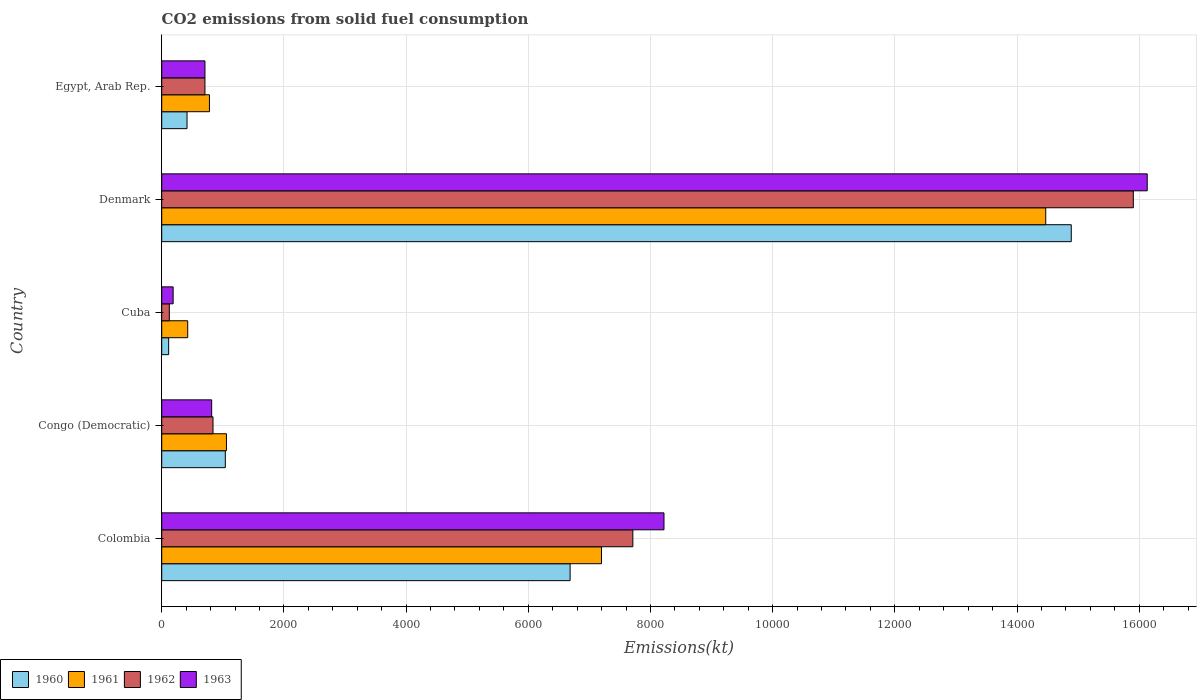Are the number of bars on each tick of the Y-axis equal?
Your response must be concise. Yes. What is the label of the 3rd group of bars from the top?
Offer a terse response. Cuba. What is the amount of CO2 emitted in 1963 in Cuba?
Keep it short and to the point. 187.02. Across all countries, what is the maximum amount of CO2 emitted in 1963?
Keep it short and to the point. 1.61e+04. Across all countries, what is the minimum amount of CO2 emitted in 1961?
Provide a succinct answer. 425.37. In which country was the amount of CO2 emitted in 1961 maximum?
Provide a succinct answer. Denmark. In which country was the amount of CO2 emitted in 1961 minimum?
Give a very brief answer. Cuba. What is the total amount of CO2 emitted in 1962 in the graph?
Make the answer very short. 2.53e+04. What is the difference between the amount of CO2 emitted in 1961 in Colombia and that in Egypt, Arab Rep.?
Offer a terse response. 6417.25. What is the difference between the amount of CO2 emitted in 1962 in Congo (Democratic) and the amount of CO2 emitted in 1963 in Colombia?
Offer a terse response. -7381.67. What is the average amount of CO2 emitted in 1960 per country?
Make the answer very short. 4628.49. What is the difference between the amount of CO2 emitted in 1962 and amount of CO2 emitted in 1961 in Denmark?
Provide a short and direct response. 1433.8. What is the ratio of the amount of CO2 emitted in 1961 in Congo (Democratic) to that in Egypt, Arab Rep.?
Ensure brevity in your answer.  1.36. Is the amount of CO2 emitted in 1960 in Congo (Democratic) less than that in Cuba?
Make the answer very short. No. Is the difference between the amount of CO2 emitted in 1962 in Cuba and Denmark greater than the difference between the amount of CO2 emitted in 1961 in Cuba and Denmark?
Make the answer very short. No. What is the difference between the highest and the second highest amount of CO2 emitted in 1961?
Provide a short and direct response. 7271.66. What is the difference between the highest and the lowest amount of CO2 emitted in 1960?
Offer a very short reply. 1.48e+04. Is it the case that in every country, the sum of the amount of CO2 emitted in 1962 and amount of CO2 emitted in 1963 is greater than the sum of amount of CO2 emitted in 1961 and amount of CO2 emitted in 1960?
Provide a succinct answer. No. What does the 3rd bar from the top in Cuba represents?
Provide a short and direct response. 1961. What does the 2nd bar from the bottom in Colombia represents?
Your response must be concise. 1961. Is it the case that in every country, the sum of the amount of CO2 emitted in 1960 and amount of CO2 emitted in 1961 is greater than the amount of CO2 emitted in 1962?
Ensure brevity in your answer.  Yes. How many bars are there?
Offer a terse response. 20. Are all the bars in the graph horizontal?
Offer a very short reply. Yes. Are the values on the major ticks of X-axis written in scientific E-notation?
Keep it short and to the point. No. Does the graph contain grids?
Provide a short and direct response. Yes. How many legend labels are there?
Your answer should be compact. 4. How are the legend labels stacked?
Your answer should be compact. Horizontal. What is the title of the graph?
Provide a short and direct response. CO2 emissions from solid fuel consumption. Does "1973" appear as one of the legend labels in the graph?
Your response must be concise. No. What is the label or title of the X-axis?
Give a very brief answer. Emissions(kt). What is the Emissions(kt) in 1960 in Colombia?
Offer a very short reply. 6684.94. What is the Emissions(kt) of 1961 in Colombia?
Your response must be concise. 7198.32. What is the Emissions(kt) in 1962 in Colombia?
Provide a succinct answer. 7711.7. What is the Emissions(kt) of 1963 in Colombia?
Your answer should be compact. 8221.41. What is the Emissions(kt) in 1960 in Congo (Democratic)?
Offer a very short reply. 1041.43. What is the Emissions(kt) of 1961 in Congo (Democratic)?
Offer a very short reply. 1059.76. What is the Emissions(kt) in 1962 in Congo (Democratic)?
Make the answer very short. 839.74. What is the Emissions(kt) of 1963 in Congo (Democratic)?
Ensure brevity in your answer.  817.74. What is the Emissions(kt) of 1960 in Cuba?
Offer a terse response. 113.68. What is the Emissions(kt) of 1961 in Cuba?
Make the answer very short. 425.37. What is the Emissions(kt) in 1962 in Cuba?
Provide a short and direct response. 124.68. What is the Emissions(kt) in 1963 in Cuba?
Your answer should be compact. 187.02. What is the Emissions(kt) in 1960 in Denmark?
Your answer should be very brief. 1.49e+04. What is the Emissions(kt) in 1961 in Denmark?
Make the answer very short. 1.45e+04. What is the Emissions(kt) in 1962 in Denmark?
Ensure brevity in your answer.  1.59e+04. What is the Emissions(kt) in 1963 in Denmark?
Your answer should be compact. 1.61e+04. What is the Emissions(kt) of 1960 in Egypt, Arab Rep.?
Offer a terse response. 414.37. What is the Emissions(kt) in 1961 in Egypt, Arab Rep.?
Offer a very short reply. 781.07. What is the Emissions(kt) in 1962 in Egypt, Arab Rep.?
Keep it short and to the point. 707.73. What is the Emissions(kt) in 1963 in Egypt, Arab Rep.?
Offer a terse response. 707.73. Across all countries, what is the maximum Emissions(kt) in 1960?
Your answer should be compact. 1.49e+04. Across all countries, what is the maximum Emissions(kt) of 1961?
Give a very brief answer. 1.45e+04. Across all countries, what is the maximum Emissions(kt) of 1962?
Provide a short and direct response. 1.59e+04. Across all countries, what is the maximum Emissions(kt) in 1963?
Offer a very short reply. 1.61e+04. Across all countries, what is the minimum Emissions(kt) of 1960?
Your answer should be very brief. 113.68. Across all countries, what is the minimum Emissions(kt) in 1961?
Keep it short and to the point. 425.37. Across all countries, what is the minimum Emissions(kt) of 1962?
Keep it short and to the point. 124.68. Across all countries, what is the minimum Emissions(kt) in 1963?
Offer a terse response. 187.02. What is the total Emissions(kt) in 1960 in the graph?
Give a very brief answer. 2.31e+04. What is the total Emissions(kt) in 1961 in the graph?
Make the answer very short. 2.39e+04. What is the total Emissions(kt) in 1962 in the graph?
Your response must be concise. 2.53e+04. What is the total Emissions(kt) of 1963 in the graph?
Keep it short and to the point. 2.61e+04. What is the difference between the Emissions(kt) in 1960 in Colombia and that in Congo (Democratic)?
Give a very brief answer. 5643.51. What is the difference between the Emissions(kt) of 1961 in Colombia and that in Congo (Democratic)?
Your answer should be very brief. 6138.56. What is the difference between the Emissions(kt) of 1962 in Colombia and that in Congo (Democratic)?
Your answer should be compact. 6871.96. What is the difference between the Emissions(kt) of 1963 in Colombia and that in Congo (Democratic)?
Provide a succinct answer. 7403.67. What is the difference between the Emissions(kt) in 1960 in Colombia and that in Cuba?
Keep it short and to the point. 6571.26. What is the difference between the Emissions(kt) in 1961 in Colombia and that in Cuba?
Your response must be concise. 6772.95. What is the difference between the Emissions(kt) of 1962 in Colombia and that in Cuba?
Your response must be concise. 7587.02. What is the difference between the Emissions(kt) of 1963 in Colombia and that in Cuba?
Your answer should be very brief. 8034.4. What is the difference between the Emissions(kt) of 1960 in Colombia and that in Denmark?
Offer a terse response. -8203.08. What is the difference between the Emissions(kt) of 1961 in Colombia and that in Denmark?
Provide a succinct answer. -7271.66. What is the difference between the Emissions(kt) of 1962 in Colombia and that in Denmark?
Provide a succinct answer. -8192.08. What is the difference between the Emissions(kt) in 1963 in Colombia and that in Denmark?
Keep it short and to the point. -7909.72. What is the difference between the Emissions(kt) of 1960 in Colombia and that in Egypt, Arab Rep.?
Provide a succinct answer. 6270.57. What is the difference between the Emissions(kt) in 1961 in Colombia and that in Egypt, Arab Rep.?
Ensure brevity in your answer.  6417.25. What is the difference between the Emissions(kt) of 1962 in Colombia and that in Egypt, Arab Rep.?
Ensure brevity in your answer.  7003.97. What is the difference between the Emissions(kt) in 1963 in Colombia and that in Egypt, Arab Rep.?
Offer a terse response. 7513.68. What is the difference between the Emissions(kt) of 1960 in Congo (Democratic) and that in Cuba?
Offer a terse response. 927.75. What is the difference between the Emissions(kt) of 1961 in Congo (Democratic) and that in Cuba?
Make the answer very short. 634.39. What is the difference between the Emissions(kt) in 1962 in Congo (Democratic) and that in Cuba?
Provide a short and direct response. 715.07. What is the difference between the Emissions(kt) in 1963 in Congo (Democratic) and that in Cuba?
Keep it short and to the point. 630.72. What is the difference between the Emissions(kt) in 1960 in Congo (Democratic) and that in Denmark?
Offer a very short reply. -1.38e+04. What is the difference between the Emissions(kt) in 1961 in Congo (Democratic) and that in Denmark?
Offer a very short reply. -1.34e+04. What is the difference between the Emissions(kt) in 1962 in Congo (Democratic) and that in Denmark?
Your response must be concise. -1.51e+04. What is the difference between the Emissions(kt) in 1963 in Congo (Democratic) and that in Denmark?
Your response must be concise. -1.53e+04. What is the difference between the Emissions(kt) of 1960 in Congo (Democratic) and that in Egypt, Arab Rep.?
Keep it short and to the point. 627.06. What is the difference between the Emissions(kt) in 1961 in Congo (Democratic) and that in Egypt, Arab Rep.?
Give a very brief answer. 278.69. What is the difference between the Emissions(kt) in 1962 in Congo (Democratic) and that in Egypt, Arab Rep.?
Keep it short and to the point. 132.01. What is the difference between the Emissions(kt) in 1963 in Congo (Democratic) and that in Egypt, Arab Rep.?
Make the answer very short. 110.01. What is the difference between the Emissions(kt) in 1960 in Cuba and that in Denmark?
Offer a very short reply. -1.48e+04. What is the difference between the Emissions(kt) of 1961 in Cuba and that in Denmark?
Offer a terse response. -1.40e+04. What is the difference between the Emissions(kt) in 1962 in Cuba and that in Denmark?
Ensure brevity in your answer.  -1.58e+04. What is the difference between the Emissions(kt) of 1963 in Cuba and that in Denmark?
Provide a succinct answer. -1.59e+04. What is the difference between the Emissions(kt) in 1960 in Cuba and that in Egypt, Arab Rep.?
Make the answer very short. -300.69. What is the difference between the Emissions(kt) of 1961 in Cuba and that in Egypt, Arab Rep.?
Keep it short and to the point. -355.7. What is the difference between the Emissions(kt) in 1962 in Cuba and that in Egypt, Arab Rep.?
Provide a short and direct response. -583.05. What is the difference between the Emissions(kt) in 1963 in Cuba and that in Egypt, Arab Rep.?
Your response must be concise. -520.71. What is the difference between the Emissions(kt) in 1960 in Denmark and that in Egypt, Arab Rep.?
Your answer should be very brief. 1.45e+04. What is the difference between the Emissions(kt) of 1961 in Denmark and that in Egypt, Arab Rep.?
Ensure brevity in your answer.  1.37e+04. What is the difference between the Emissions(kt) in 1962 in Denmark and that in Egypt, Arab Rep.?
Your response must be concise. 1.52e+04. What is the difference between the Emissions(kt) of 1963 in Denmark and that in Egypt, Arab Rep.?
Your answer should be very brief. 1.54e+04. What is the difference between the Emissions(kt) of 1960 in Colombia and the Emissions(kt) of 1961 in Congo (Democratic)?
Keep it short and to the point. 5625.18. What is the difference between the Emissions(kt) of 1960 in Colombia and the Emissions(kt) of 1962 in Congo (Democratic)?
Provide a succinct answer. 5845.2. What is the difference between the Emissions(kt) in 1960 in Colombia and the Emissions(kt) in 1963 in Congo (Democratic)?
Provide a succinct answer. 5867.2. What is the difference between the Emissions(kt) of 1961 in Colombia and the Emissions(kt) of 1962 in Congo (Democratic)?
Offer a terse response. 6358.58. What is the difference between the Emissions(kt) of 1961 in Colombia and the Emissions(kt) of 1963 in Congo (Democratic)?
Give a very brief answer. 6380.58. What is the difference between the Emissions(kt) of 1962 in Colombia and the Emissions(kt) of 1963 in Congo (Democratic)?
Offer a very short reply. 6893.96. What is the difference between the Emissions(kt) in 1960 in Colombia and the Emissions(kt) in 1961 in Cuba?
Provide a short and direct response. 6259.57. What is the difference between the Emissions(kt) in 1960 in Colombia and the Emissions(kt) in 1962 in Cuba?
Make the answer very short. 6560.26. What is the difference between the Emissions(kt) of 1960 in Colombia and the Emissions(kt) of 1963 in Cuba?
Your response must be concise. 6497.92. What is the difference between the Emissions(kt) in 1961 in Colombia and the Emissions(kt) in 1962 in Cuba?
Provide a short and direct response. 7073.64. What is the difference between the Emissions(kt) of 1961 in Colombia and the Emissions(kt) of 1963 in Cuba?
Your answer should be compact. 7011.3. What is the difference between the Emissions(kt) in 1962 in Colombia and the Emissions(kt) in 1963 in Cuba?
Give a very brief answer. 7524.68. What is the difference between the Emissions(kt) in 1960 in Colombia and the Emissions(kt) in 1961 in Denmark?
Your answer should be compact. -7785.04. What is the difference between the Emissions(kt) in 1960 in Colombia and the Emissions(kt) in 1962 in Denmark?
Provide a succinct answer. -9218.84. What is the difference between the Emissions(kt) in 1960 in Colombia and the Emissions(kt) in 1963 in Denmark?
Provide a short and direct response. -9446.19. What is the difference between the Emissions(kt) of 1961 in Colombia and the Emissions(kt) of 1962 in Denmark?
Offer a terse response. -8705.46. What is the difference between the Emissions(kt) in 1961 in Colombia and the Emissions(kt) in 1963 in Denmark?
Your answer should be very brief. -8932.81. What is the difference between the Emissions(kt) of 1962 in Colombia and the Emissions(kt) of 1963 in Denmark?
Your response must be concise. -8419.43. What is the difference between the Emissions(kt) of 1960 in Colombia and the Emissions(kt) of 1961 in Egypt, Arab Rep.?
Give a very brief answer. 5903.87. What is the difference between the Emissions(kt) in 1960 in Colombia and the Emissions(kt) in 1962 in Egypt, Arab Rep.?
Provide a short and direct response. 5977.21. What is the difference between the Emissions(kt) in 1960 in Colombia and the Emissions(kt) in 1963 in Egypt, Arab Rep.?
Make the answer very short. 5977.21. What is the difference between the Emissions(kt) of 1961 in Colombia and the Emissions(kt) of 1962 in Egypt, Arab Rep.?
Provide a succinct answer. 6490.59. What is the difference between the Emissions(kt) in 1961 in Colombia and the Emissions(kt) in 1963 in Egypt, Arab Rep.?
Provide a succinct answer. 6490.59. What is the difference between the Emissions(kt) in 1962 in Colombia and the Emissions(kt) in 1963 in Egypt, Arab Rep.?
Keep it short and to the point. 7003.97. What is the difference between the Emissions(kt) in 1960 in Congo (Democratic) and the Emissions(kt) in 1961 in Cuba?
Your answer should be compact. 616.06. What is the difference between the Emissions(kt) of 1960 in Congo (Democratic) and the Emissions(kt) of 1962 in Cuba?
Give a very brief answer. 916.75. What is the difference between the Emissions(kt) in 1960 in Congo (Democratic) and the Emissions(kt) in 1963 in Cuba?
Provide a succinct answer. 854.41. What is the difference between the Emissions(kt) in 1961 in Congo (Democratic) and the Emissions(kt) in 1962 in Cuba?
Keep it short and to the point. 935.09. What is the difference between the Emissions(kt) in 1961 in Congo (Democratic) and the Emissions(kt) in 1963 in Cuba?
Make the answer very short. 872.75. What is the difference between the Emissions(kt) in 1962 in Congo (Democratic) and the Emissions(kt) in 1963 in Cuba?
Make the answer very short. 652.73. What is the difference between the Emissions(kt) of 1960 in Congo (Democratic) and the Emissions(kt) of 1961 in Denmark?
Your response must be concise. -1.34e+04. What is the difference between the Emissions(kt) of 1960 in Congo (Democratic) and the Emissions(kt) of 1962 in Denmark?
Provide a succinct answer. -1.49e+04. What is the difference between the Emissions(kt) of 1960 in Congo (Democratic) and the Emissions(kt) of 1963 in Denmark?
Offer a very short reply. -1.51e+04. What is the difference between the Emissions(kt) in 1961 in Congo (Democratic) and the Emissions(kt) in 1962 in Denmark?
Offer a very short reply. -1.48e+04. What is the difference between the Emissions(kt) in 1961 in Congo (Democratic) and the Emissions(kt) in 1963 in Denmark?
Your response must be concise. -1.51e+04. What is the difference between the Emissions(kt) of 1962 in Congo (Democratic) and the Emissions(kt) of 1963 in Denmark?
Offer a terse response. -1.53e+04. What is the difference between the Emissions(kt) in 1960 in Congo (Democratic) and the Emissions(kt) in 1961 in Egypt, Arab Rep.?
Your answer should be compact. 260.36. What is the difference between the Emissions(kt) in 1960 in Congo (Democratic) and the Emissions(kt) in 1962 in Egypt, Arab Rep.?
Make the answer very short. 333.7. What is the difference between the Emissions(kt) in 1960 in Congo (Democratic) and the Emissions(kt) in 1963 in Egypt, Arab Rep.?
Provide a short and direct response. 333.7. What is the difference between the Emissions(kt) in 1961 in Congo (Democratic) and the Emissions(kt) in 1962 in Egypt, Arab Rep.?
Make the answer very short. 352.03. What is the difference between the Emissions(kt) in 1961 in Congo (Democratic) and the Emissions(kt) in 1963 in Egypt, Arab Rep.?
Provide a short and direct response. 352.03. What is the difference between the Emissions(kt) in 1962 in Congo (Democratic) and the Emissions(kt) in 1963 in Egypt, Arab Rep.?
Your answer should be compact. 132.01. What is the difference between the Emissions(kt) of 1960 in Cuba and the Emissions(kt) of 1961 in Denmark?
Make the answer very short. -1.44e+04. What is the difference between the Emissions(kt) of 1960 in Cuba and the Emissions(kt) of 1962 in Denmark?
Your answer should be compact. -1.58e+04. What is the difference between the Emissions(kt) in 1960 in Cuba and the Emissions(kt) in 1963 in Denmark?
Keep it short and to the point. -1.60e+04. What is the difference between the Emissions(kt) in 1961 in Cuba and the Emissions(kt) in 1962 in Denmark?
Offer a terse response. -1.55e+04. What is the difference between the Emissions(kt) in 1961 in Cuba and the Emissions(kt) in 1963 in Denmark?
Give a very brief answer. -1.57e+04. What is the difference between the Emissions(kt) in 1962 in Cuba and the Emissions(kt) in 1963 in Denmark?
Make the answer very short. -1.60e+04. What is the difference between the Emissions(kt) of 1960 in Cuba and the Emissions(kt) of 1961 in Egypt, Arab Rep.?
Your response must be concise. -667.39. What is the difference between the Emissions(kt) in 1960 in Cuba and the Emissions(kt) in 1962 in Egypt, Arab Rep.?
Ensure brevity in your answer.  -594.05. What is the difference between the Emissions(kt) in 1960 in Cuba and the Emissions(kt) in 1963 in Egypt, Arab Rep.?
Keep it short and to the point. -594.05. What is the difference between the Emissions(kt) of 1961 in Cuba and the Emissions(kt) of 1962 in Egypt, Arab Rep.?
Provide a short and direct response. -282.36. What is the difference between the Emissions(kt) of 1961 in Cuba and the Emissions(kt) of 1963 in Egypt, Arab Rep.?
Offer a very short reply. -282.36. What is the difference between the Emissions(kt) of 1962 in Cuba and the Emissions(kt) of 1963 in Egypt, Arab Rep.?
Your response must be concise. -583.05. What is the difference between the Emissions(kt) of 1960 in Denmark and the Emissions(kt) of 1961 in Egypt, Arab Rep.?
Your answer should be compact. 1.41e+04. What is the difference between the Emissions(kt) of 1960 in Denmark and the Emissions(kt) of 1962 in Egypt, Arab Rep.?
Offer a very short reply. 1.42e+04. What is the difference between the Emissions(kt) of 1960 in Denmark and the Emissions(kt) of 1963 in Egypt, Arab Rep.?
Ensure brevity in your answer.  1.42e+04. What is the difference between the Emissions(kt) of 1961 in Denmark and the Emissions(kt) of 1962 in Egypt, Arab Rep.?
Offer a very short reply. 1.38e+04. What is the difference between the Emissions(kt) of 1961 in Denmark and the Emissions(kt) of 1963 in Egypt, Arab Rep.?
Your answer should be compact. 1.38e+04. What is the difference between the Emissions(kt) of 1962 in Denmark and the Emissions(kt) of 1963 in Egypt, Arab Rep.?
Offer a very short reply. 1.52e+04. What is the average Emissions(kt) in 1960 per country?
Your answer should be compact. 4628.49. What is the average Emissions(kt) in 1961 per country?
Give a very brief answer. 4786.9. What is the average Emissions(kt) of 1962 per country?
Make the answer very short. 5057.53. What is the average Emissions(kt) of 1963 per country?
Your answer should be very brief. 5213.01. What is the difference between the Emissions(kt) in 1960 and Emissions(kt) in 1961 in Colombia?
Give a very brief answer. -513.38. What is the difference between the Emissions(kt) in 1960 and Emissions(kt) in 1962 in Colombia?
Keep it short and to the point. -1026.76. What is the difference between the Emissions(kt) in 1960 and Emissions(kt) in 1963 in Colombia?
Provide a short and direct response. -1536.47. What is the difference between the Emissions(kt) in 1961 and Emissions(kt) in 1962 in Colombia?
Ensure brevity in your answer.  -513.38. What is the difference between the Emissions(kt) of 1961 and Emissions(kt) of 1963 in Colombia?
Offer a very short reply. -1023.09. What is the difference between the Emissions(kt) in 1962 and Emissions(kt) in 1963 in Colombia?
Give a very brief answer. -509.71. What is the difference between the Emissions(kt) of 1960 and Emissions(kt) of 1961 in Congo (Democratic)?
Ensure brevity in your answer.  -18.34. What is the difference between the Emissions(kt) of 1960 and Emissions(kt) of 1962 in Congo (Democratic)?
Make the answer very short. 201.69. What is the difference between the Emissions(kt) in 1960 and Emissions(kt) in 1963 in Congo (Democratic)?
Ensure brevity in your answer.  223.69. What is the difference between the Emissions(kt) of 1961 and Emissions(kt) of 1962 in Congo (Democratic)?
Give a very brief answer. 220.02. What is the difference between the Emissions(kt) of 1961 and Emissions(kt) of 1963 in Congo (Democratic)?
Make the answer very short. 242.02. What is the difference between the Emissions(kt) of 1962 and Emissions(kt) of 1963 in Congo (Democratic)?
Your answer should be very brief. 22. What is the difference between the Emissions(kt) of 1960 and Emissions(kt) of 1961 in Cuba?
Keep it short and to the point. -311.69. What is the difference between the Emissions(kt) of 1960 and Emissions(kt) of 1962 in Cuba?
Provide a succinct answer. -11. What is the difference between the Emissions(kt) of 1960 and Emissions(kt) of 1963 in Cuba?
Provide a short and direct response. -73.34. What is the difference between the Emissions(kt) in 1961 and Emissions(kt) in 1962 in Cuba?
Offer a very short reply. 300.69. What is the difference between the Emissions(kt) of 1961 and Emissions(kt) of 1963 in Cuba?
Provide a short and direct response. 238.35. What is the difference between the Emissions(kt) of 1962 and Emissions(kt) of 1963 in Cuba?
Give a very brief answer. -62.34. What is the difference between the Emissions(kt) in 1960 and Emissions(kt) in 1961 in Denmark?
Provide a succinct answer. 418.04. What is the difference between the Emissions(kt) in 1960 and Emissions(kt) in 1962 in Denmark?
Give a very brief answer. -1015.76. What is the difference between the Emissions(kt) in 1960 and Emissions(kt) in 1963 in Denmark?
Provide a short and direct response. -1243.11. What is the difference between the Emissions(kt) of 1961 and Emissions(kt) of 1962 in Denmark?
Provide a succinct answer. -1433.8. What is the difference between the Emissions(kt) in 1961 and Emissions(kt) in 1963 in Denmark?
Provide a succinct answer. -1661.15. What is the difference between the Emissions(kt) of 1962 and Emissions(kt) of 1963 in Denmark?
Provide a short and direct response. -227.35. What is the difference between the Emissions(kt) of 1960 and Emissions(kt) of 1961 in Egypt, Arab Rep.?
Make the answer very short. -366.7. What is the difference between the Emissions(kt) of 1960 and Emissions(kt) of 1962 in Egypt, Arab Rep.?
Your response must be concise. -293.36. What is the difference between the Emissions(kt) in 1960 and Emissions(kt) in 1963 in Egypt, Arab Rep.?
Ensure brevity in your answer.  -293.36. What is the difference between the Emissions(kt) in 1961 and Emissions(kt) in 1962 in Egypt, Arab Rep.?
Provide a short and direct response. 73.34. What is the difference between the Emissions(kt) of 1961 and Emissions(kt) of 1963 in Egypt, Arab Rep.?
Your answer should be compact. 73.34. What is the difference between the Emissions(kt) of 1962 and Emissions(kt) of 1963 in Egypt, Arab Rep.?
Offer a very short reply. 0. What is the ratio of the Emissions(kt) in 1960 in Colombia to that in Congo (Democratic)?
Offer a terse response. 6.42. What is the ratio of the Emissions(kt) in 1961 in Colombia to that in Congo (Democratic)?
Provide a short and direct response. 6.79. What is the ratio of the Emissions(kt) in 1962 in Colombia to that in Congo (Democratic)?
Ensure brevity in your answer.  9.18. What is the ratio of the Emissions(kt) of 1963 in Colombia to that in Congo (Democratic)?
Offer a terse response. 10.05. What is the ratio of the Emissions(kt) in 1960 in Colombia to that in Cuba?
Make the answer very short. 58.81. What is the ratio of the Emissions(kt) of 1961 in Colombia to that in Cuba?
Your response must be concise. 16.92. What is the ratio of the Emissions(kt) in 1962 in Colombia to that in Cuba?
Make the answer very short. 61.85. What is the ratio of the Emissions(kt) in 1963 in Colombia to that in Cuba?
Keep it short and to the point. 43.96. What is the ratio of the Emissions(kt) of 1960 in Colombia to that in Denmark?
Make the answer very short. 0.45. What is the ratio of the Emissions(kt) of 1961 in Colombia to that in Denmark?
Your answer should be very brief. 0.5. What is the ratio of the Emissions(kt) in 1962 in Colombia to that in Denmark?
Provide a short and direct response. 0.48. What is the ratio of the Emissions(kt) of 1963 in Colombia to that in Denmark?
Offer a terse response. 0.51. What is the ratio of the Emissions(kt) in 1960 in Colombia to that in Egypt, Arab Rep.?
Your response must be concise. 16.13. What is the ratio of the Emissions(kt) of 1961 in Colombia to that in Egypt, Arab Rep.?
Your answer should be very brief. 9.22. What is the ratio of the Emissions(kt) of 1962 in Colombia to that in Egypt, Arab Rep.?
Provide a succinct answer. 10.9. What is the ratio of the Emissions(kt) of 1963 in Colombia to that in Egypt, Arab Rep.?
Ensure brevity in your answer.  11.62. What is the ratio of the Emissions(kt) in 1960 in Congo (Democratic) to that in Cuba?
Ensure brevity in your answer.  9.16. What is the ratio of the Emissions(kt) in 1961 in Congo (Democratic) to that in Cuba?
Offer a terse response. 2.49. What is the ratio of the Emissions(kt) in 1962 in Congo (Democratic) to that in Cuba?
Your response must be concise. 6.74. What is the ratio of the Emissions(kt) of 1963 in Congo (Democratic) to that in Cuba?
Offer a very short reply. 4.37. What is the ratio of the Emissions(kt) of 1960 in Congo (Democratic) to that in Denmark?
Offer a very short reply. 0.07. What is the ratio of the Emissions(kt) of 1961 in Congo (Democratic) to that in Denmark?
Your response must be concise. 0.07. What is the ratio of the Emissions(kt) of 1962 in Congo (Democratic) to that in Denmark?
Make the answer very short. 0.05. What is the ratio of the Emissions(kt) of 1963 in Congo (Democratic) to that in Denmark?
Ensure brevity in your answer.  0.05. What is the ratio of the Emissions(kt) in 1960 in Congo (Democratic) to that in Egypt, Arab Rep.?
Make the answer very short. 2.51. What is the ratio of the Emissions(kt) of 1961 in Congo (Democratic) to that in Egypt, Arab Rep.?
Ensure brevity in your answer.  1.36. What is the ratio of the Emissions(kt) of 1962 in Congo (Democratic) to that in Egypt, Arab Rep.?
Make the answer very short. 1.19. What is the ratio of the Emissions(kt) in 1963 in Congo (Democratic) to that in Egypt, Arab Rep.?
Your response must be concise. 1.16. What is the ratio of the Emissions(kt) of 1960 in Cuba to that in Denmark?
Your answer should be compact. 0.01. What is the ratio of the Emissions(kt) in 1961 in Cuba to that in Denmark?
Keep it short and to the point. 0.03. What is the ratio of the Emissions(kt) in 1962 in Cuba to that in Denmark?
Make the answer very short. 0.01. What is the ratio of the Emissions(kt) of 1963 in Cuba to that in Denmark?
Provide a succinct answer. 0.01. What is the ratio of the Emissions(kt) in 1960 in Cuba to that in Egypt, Arab Rep.?
Provide a short and direct response. 0.27. What is the ratio of the Emissions(kt) of 1961 in Cuba to that in Egypt, Arab Rep.?
Offer a very short reply. 0.54. What is the ratio of the Emissions(kt) of 1962 in Cuba to that in Egypt, Arab Rep.?
Your response must be concise. 0.18. What is the ratio of the Emissions(kt) in 1963 in Cuba to that in Egypt, Arab Rep.?
Give a very brief answer. 0.26. What is the ratio of the Emissions(kt) in 1960 in Denmark to that in Egypt, Arab Rep.?
Your answer should be compact. 35.93. What is the ratio of the Emissions(kt) of 1961 in Denmark to that in Egypt, Arab Rep.?
Offer a very short reply. 18.53. What is the ratio of the Emissions(kt) in 1962 in Denmark to that in Egypt, Arab Rep.?
Provide a succinct answer. 22.47. What is the ratio of the Emissions(kt) in 1963 in Denmark to that in Egypt, Arab Rep.?
Offer a very short reply. 22.79. What is the difference between the highest and the second highest Emissions(kt) of 1960?
Give a very brief answer. 8203.08. What is the difference between the highest and the second highest Emissions(kt) in 1961?
Offer a very short reply. 7271.66. What is the difference between the highest and the second highest Emissions(kt) in 1962?
Give a very brief answer. 8192.08. What is the difference between the highest and the second highest Emissions(kt) in 1963?
Offer a terse response. 7909.72. What is the difference between the highest and the lowest Emissions(kt) of 1960?
Provide a succinct answer. 1.48e+04. What is the difference between the highest and the lowest Emissions(kt) in 1961?
Make the answer very short. 1.40e+04. What is the difference between the highest and the lowest Emissions(kt) of 1962?
Your answer should be compact. 1.58e+04. What is the difference between the highest and the lowest Emissions(kt) in 1963?
Your answer should be very brief. 1.59e+04. 